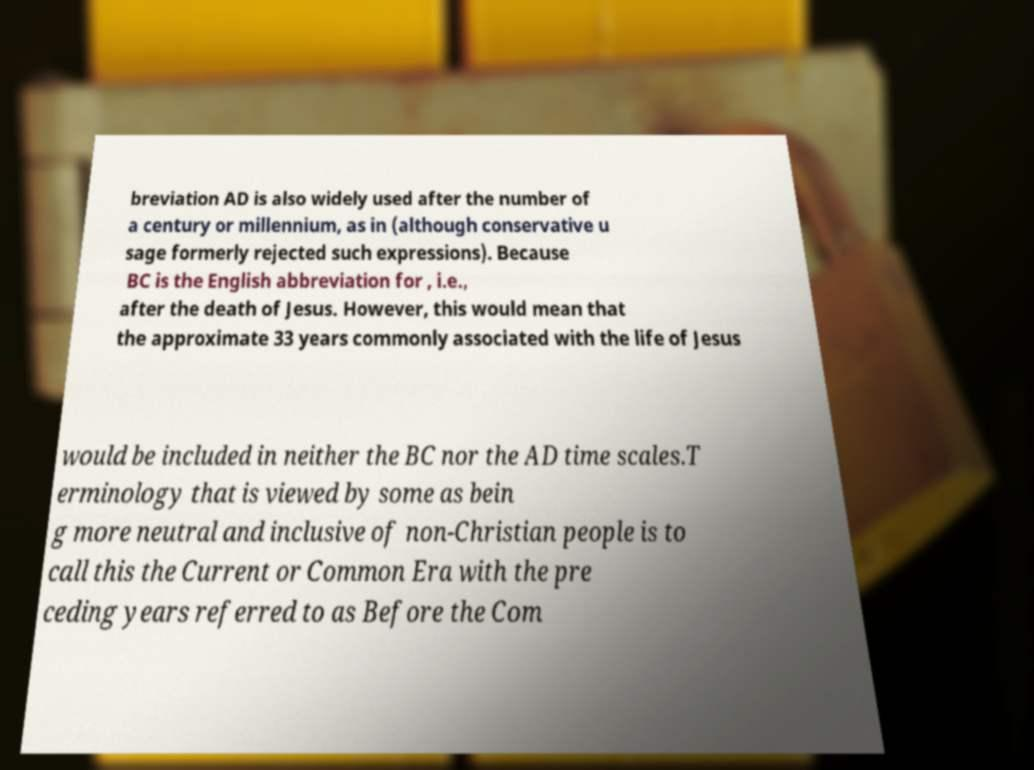Please read and relay the text visible in this image. What does it say? breviation AD is also widely used after the number of a century or millennium, as in (although conservative u sage formerly rejected such expressions). Because BC is the English abbreviation for , i.e., after the death of Jesus. However, this would mean that the approximate 33 years commonly associated with the life of Jesus would be included in neither the BC nor the AD time scales.T erminology that is viewed by some as bein g more neutral and inclusive of non-Christian people is to call this the Current or Common Era with the pre ceding years referred to as Before the Com 